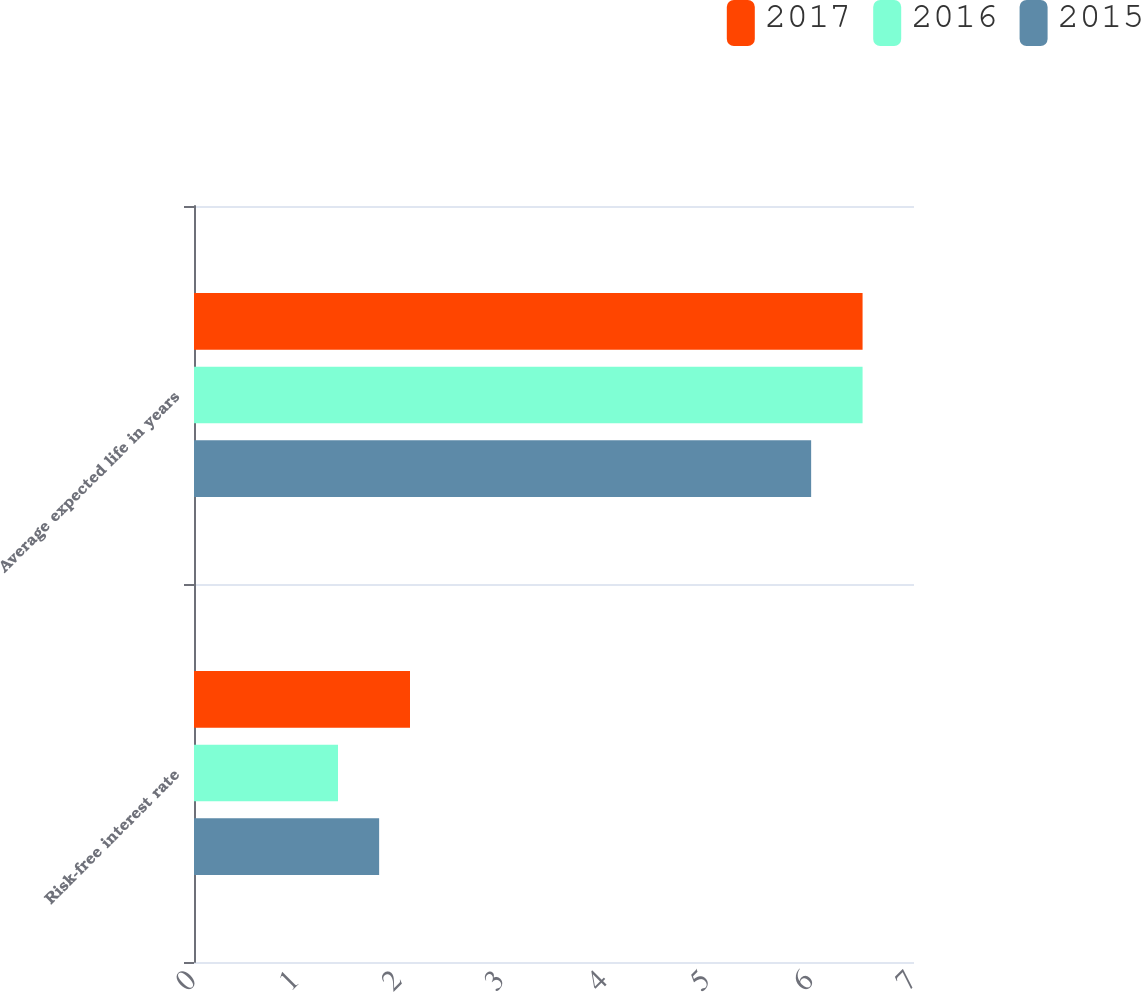<chart> <loc_0><loc_0><loc_500><loc_500><stacked_bar_chart><ecel><fcel>Risk-free interest rate<fcel>Average expected life in years<nl><fcel>2017<fcel>2.1<fcel>6.5<nl><fcel>2016<fcel>1.4<fcel>6.5<nl><fcel>2015<fcel>1.8<fcel>6<nl></chart> 